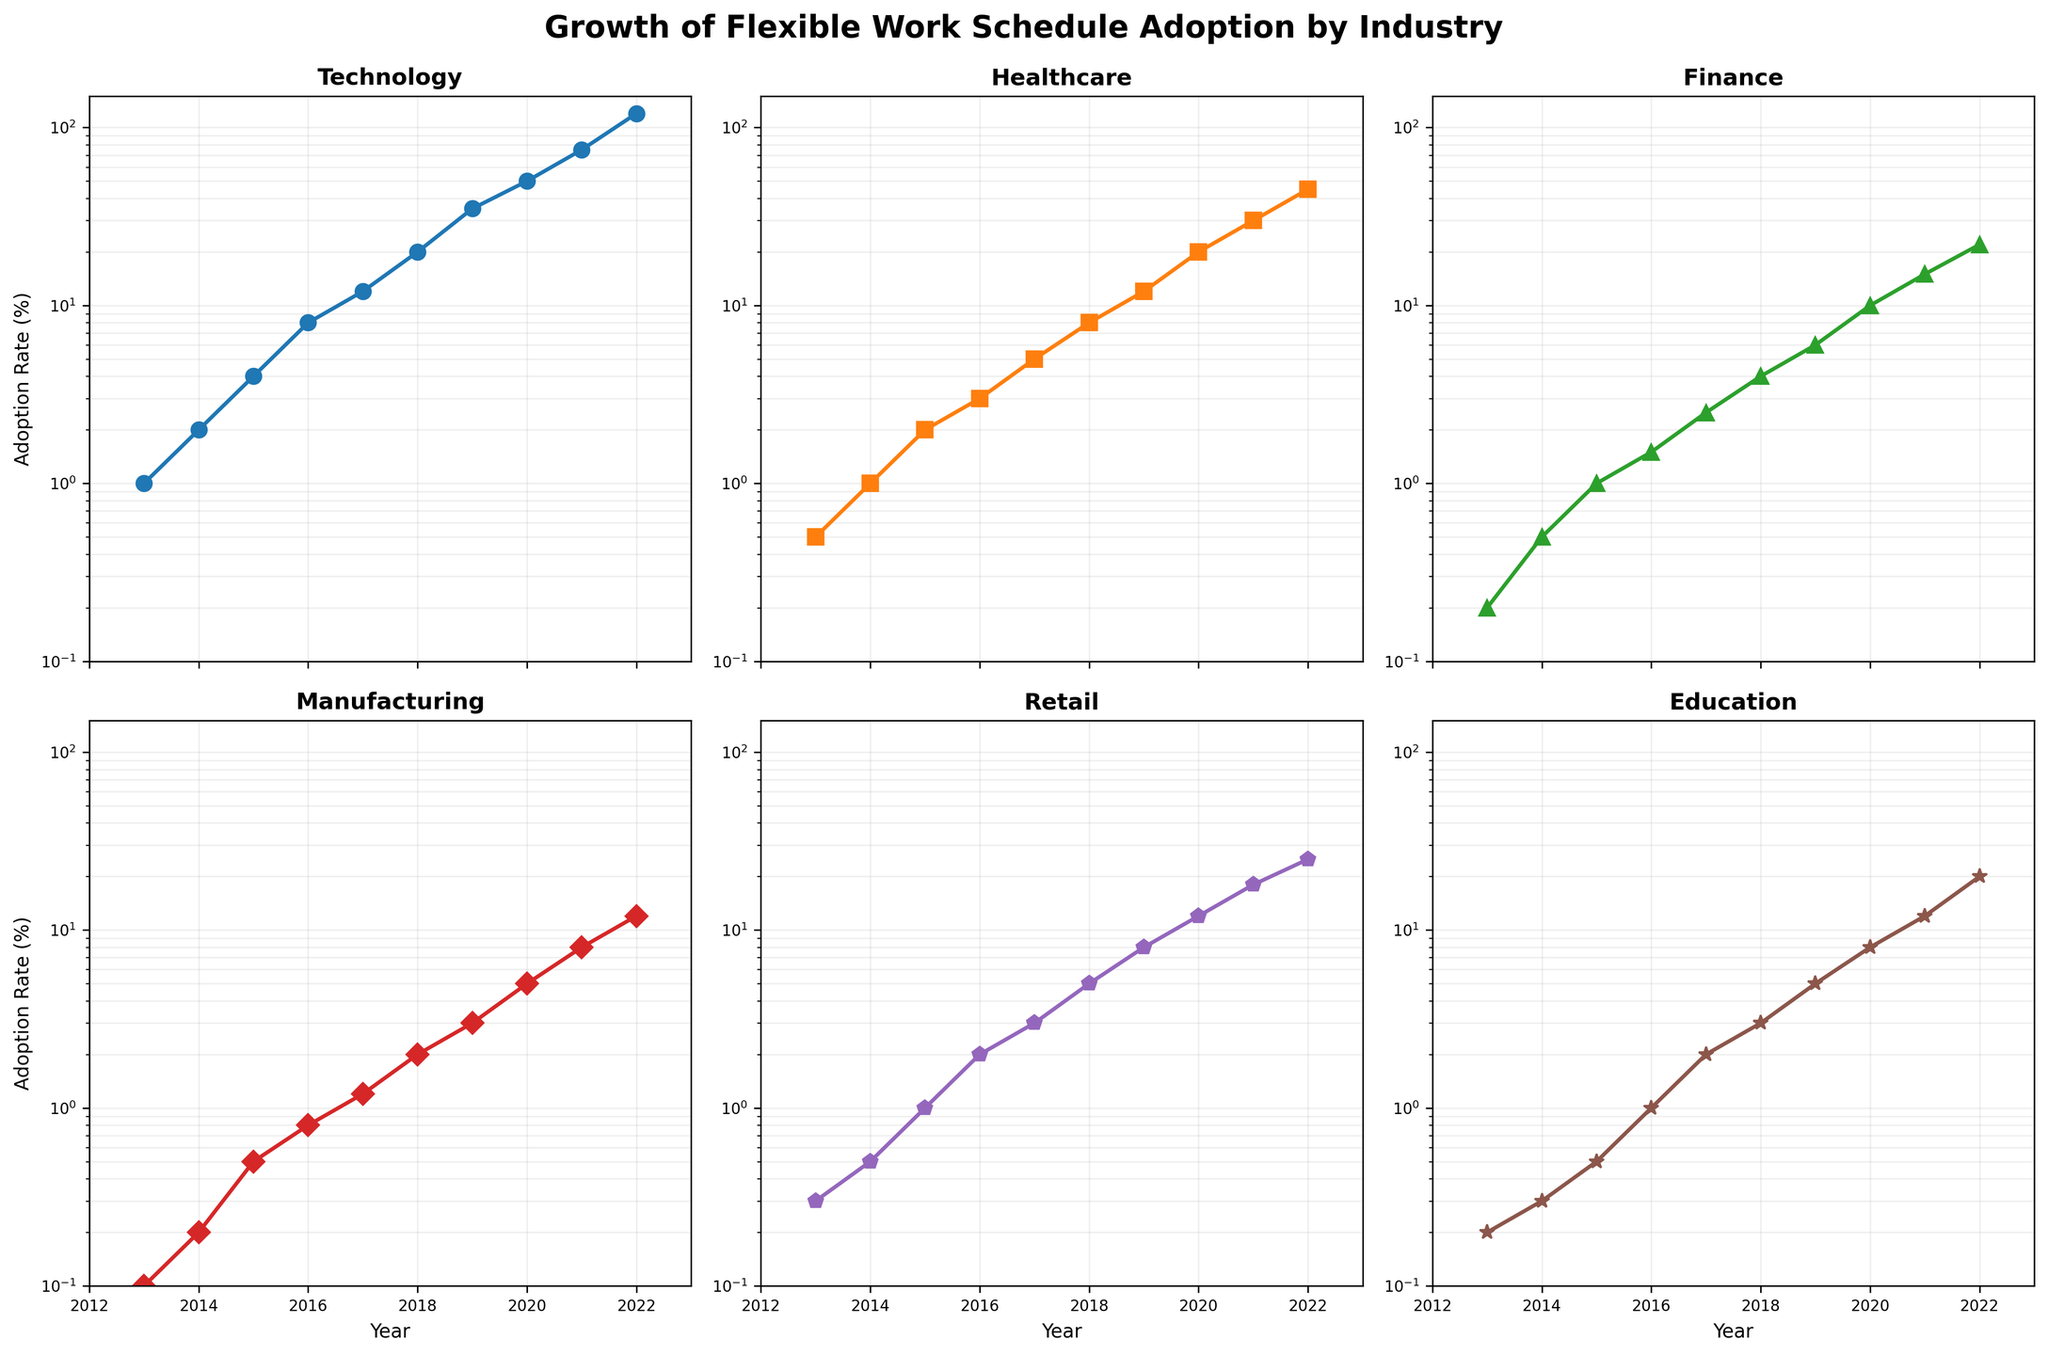what is the overall trend of flexible work schedule adoption in the technology industry? By looking at the semilogy plot for the Technology industry subplot, we see that the adoption rate has continuously increased over the past decade, starting from 1% in 2013 to 120% in 2022.
Answer: Continuous increase In which year did the healthcare industry have the highest growth rate in flexible work schedule adoption? To determine the year with the highest growth rate, we need to compare the year-over-year increments. From the plot, there is a noticeable jump in the slope between 2021 and 2022.
Answer: 2021-2022 How does the flexible work schedule adoption rate in finance compare to that of manufacturing in 2020? In 2020, the Finance subplot shows an adoption rate of 10%, while the Manufacturing subplot shows an adoption rate of 5%. Comparing the two values, Finance has a higher adoption rate.
Answer: Finance > Manufacturing What is the common adoption rate range for flexible work schedules in the retail industry from 2013 to 2022? The Retail subplot shows the adoption rate starting at 0.3% in 2013 and ending at 25% in 2022. Therefore, the common range is between 0.3% and 25%.
Answer: 0.3% to 25% Considering the log scale, which industry shows the most exponential growth in flexible work schedule adoption over the past decade? The Technology subplot shows the steepest upward slope on the log scale, indicating the most exponential growth compared to other industries.
Answer: Technology Which year saw the introduction of noticeable flexible work schedule adoption in the Education industry? Looking at the Education subplot, noticeable adoption begins around 2015 when the value starts to increase visibly from 0.5%.
Answer: 2015 Which industry had the smallest increase in flexible work schedule adoption between 2017 and 2018? By comparing the slopes between 2017 and 2018 on each subplot, Manufacturing shows the smallest increase, with an increase from 1.2% to 2%.
Answer: Manufacturing How has the adoption rate's increase between 2013 and 2022 in Healthcare compared to Education? For Healthcare, the adoption rate increased from 0.5% to 45%. For Education, the adoption rate increased from 0.2% to 20%. Comparing the two, Healthcare has a higher overall increase.
Answer: Healthcare > Education Which industry had similar adoption rates in 2016? By looking at the 2016 value on each subplot, Finance and Education both have an adoption rate of approximately 1%.
Answer: Finance and Education 